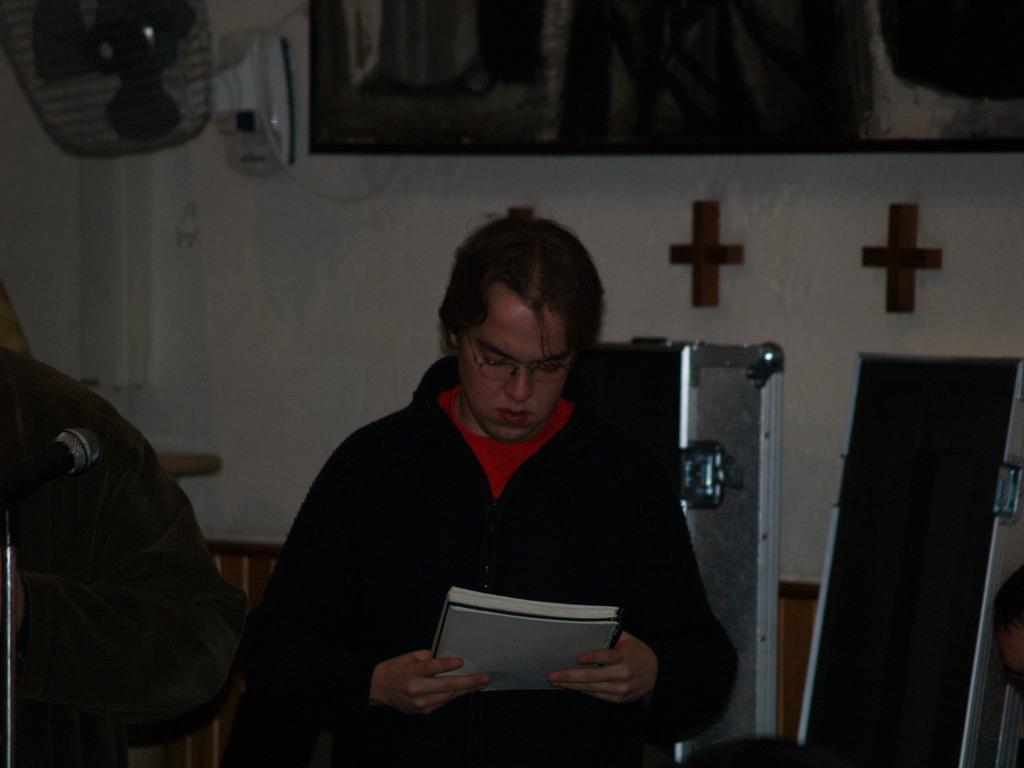Please provide a concise description of this image. The man in the middle of the picture, we see a man in red T-shirt and black jacket is holding a book in his hand. Behind him, we see the boxes. Behind that, we see a wall in white color. In the left top of the picture, we see a table fan. This picture is clicked in the dark. 